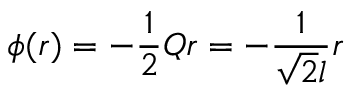Convert formula to latex. <formula><loc_0><loc_0><loc_500><loc_500>\phi ( r ) = - \frac { 1 } { 2 } Q r = - \frac { 1 } { \sqrt { 2 } l } r</formula> 